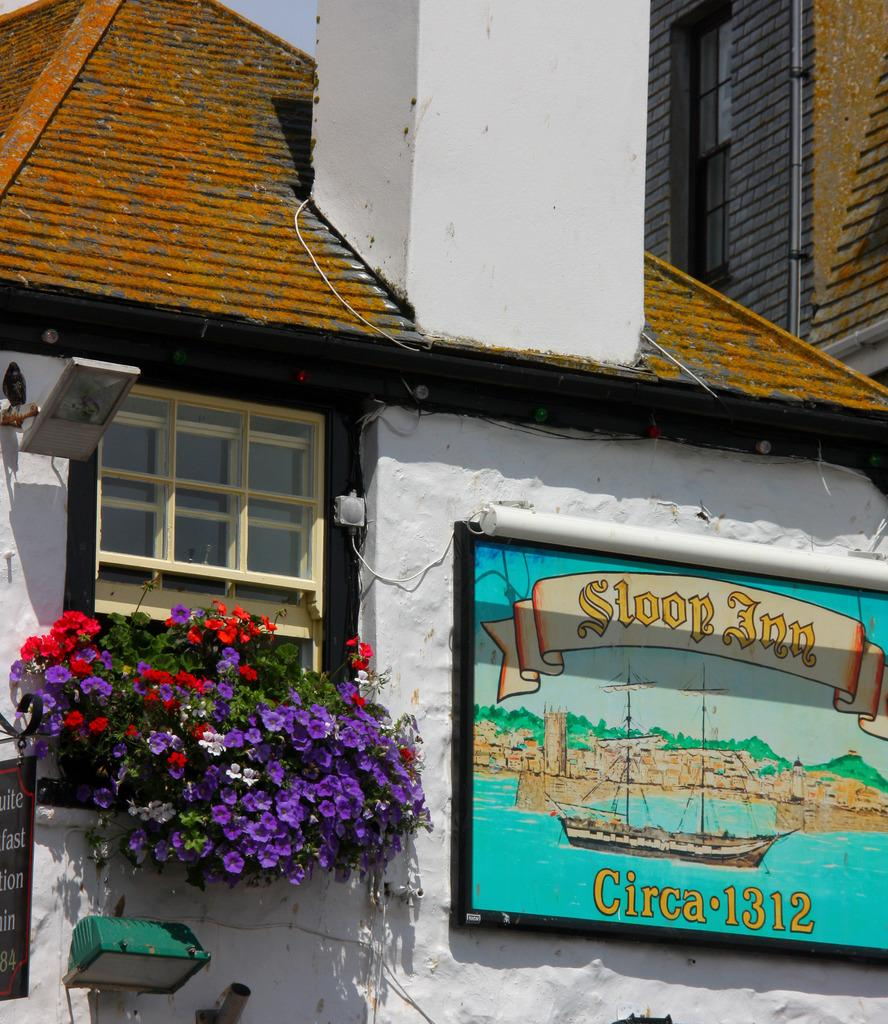What type of structures are present in the image? There are houses with walls in the image. What feature can be seen on the houses? The houses have glass windows. What type of vegetation is present in the image? There are plants with flowers in the image. What objects can be seen in the image that are made of wood or a similar material? There are boards visible in the image. What is the source of illumination in the image? There is light in the image. What architectural element is present at the top of the image? There is a white pillar at the top of the image. Can you see any bees buzzing around the flowers in the image? There are no bees visible in the image; it only shows plants with flowers. Are there any bubbles floating in the air in the image? There are no bubbles present in the image. 